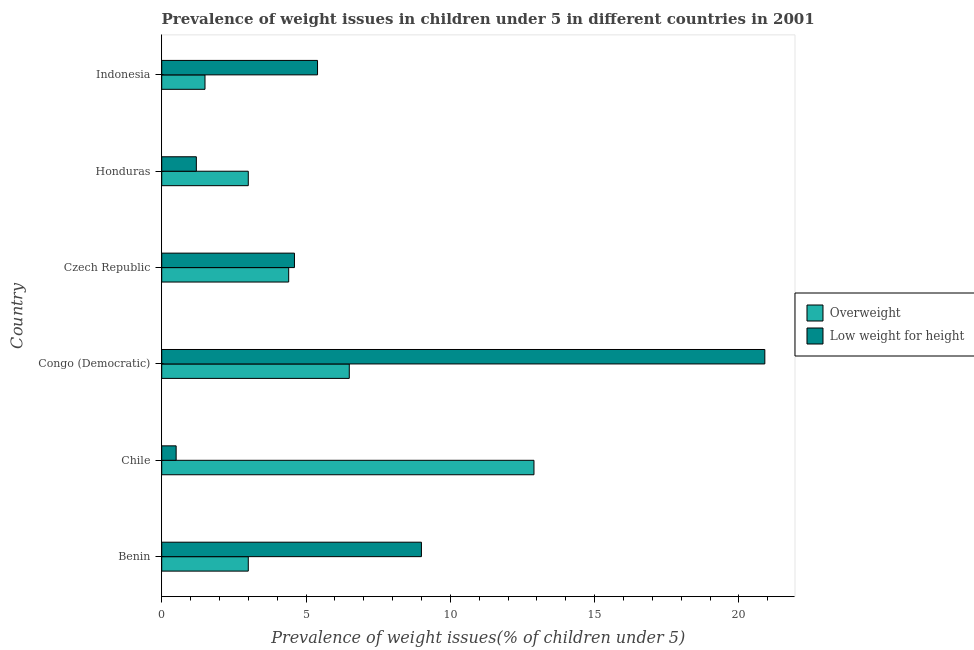How many different coloured bars are there?
Keep it short and to the point. 2. Are the number of bars per tick equal to the number of legend labels?
Offer a terse response. Yes. How many bars are there on the 5th tick from the top?
Your answer should be compact. 2. How many bars are there on the 3rd tick from the bottom?
Your response must be concise. 2. What is the label of the 3rd group of bars from the top?
Your answer should be compact. Czech Republic. Across all countries, what is the maximum percentage of overweight children?
Provide a short and direct response. 12.9. Across all countries, what is the minimum percentage of underweight children?
Your response must be concise. 0.5. What is the total percentage of overweight children in the graph?
Your response must be concise. 31.3. What is the difference between the percentage of underweight children in Benin and that in Indonesia?
Your response must be concise. 3.6. What is the difference between the percentage of overweight children in Congo (Democratic) and the percentage of underweight children in Indonesia?
Your answer should be very brief. 1.1. What is the average percentage of overweight children per country?
Provide a short and direct response. 5.22. What is the difference between the percentage of overweight children and percentage of underweight children in Congo (Democratic)?
Your answer should be very brief. -14.4. What is the ratio of the percentage of overweight children in Benin to that in Czech Republic?
Ensure brevity in your answer.  0.68. Is the percentage of underweight children in Czech Republic less than that in Honduras?
Make the answer very short. No. In how many countries, is the percentage of overweight children greater than the average percentage of overweight children taken over all countries?
Your answer should be compact. 2. What does the 2nd bar from the top in Honduras represents?
Offer a very short reply. Overweight. What does the 2nd bar from the bottom in Indonesia represents?
Make the answer very short. Low weight for height. How many bars are there?
Give a very brief answer. 12. Are the values on the major ticks of X-axis written in scientific E-notation?
Provide a short and direct response. No. Does the graph contain grids?
Provide a succinct answer. No. Where does the legend appear in the graph?
Give a very brief answer. Center right. How are the legend labels stacked?
Keep it short and to the point. Vertical. What is the title of the graph?
Offer a very short reply. Prevalence of weight issues in children under 5 in different countries in 2001. Does "Residents" appear as one of the legend labels in the graph?
Your answer should be very brief. No. What is the label or title of the X-axis?
Offer a very short reply. Prevalence of weight issues(% of children under 5). What is the Prevalence of weight issues(% of children under 5) in Overweight in Benin?
Offer a very short reply. 3. What is the Prevalence of weight issues(% of children under 5) in Overweight in Chile?
Keep it short and to the point. 12.9. What is the Prevalence of weight issues(% of children under 5) of Low weight for height in Congo (Democratic)?
Ensure brevity in your answer.  20.9. What is the Prevalence of weight issues(% of children under 5) in Overweight in Czech Republic?
Give a very brief answer. 4.4. What is the Prevalence of weight issues(% of children under 5) of Low weight for height in Czech Republic?
Your answer should be very brief. 4.6. What is the Prevalence of weight issues(% of children under 5) of Overweight in Honduras?
Keep it short and to the point. 3. What is the Prevalence of weight issues(% of children under 5) of Low weight for height in Honduras?
Ensure brevity in your answer.  1.2. What is the Prevalence of weight issues(% of children under 5) in Overweight in Indonesia?
Offer a terse response. 1.5. What is the Prevalence of weight issues(% of children under 5) in Low weight for height in Indonesia?
Your answer should be compact. 5.4. Across all countries, what is the maximum Prevalence of weight issues(% of children under 5) of Overweight?
Keep it short and to the point. 12.9. Across all countries, what is the maximum Prevalence of weight issues(% of children under 5) in Low weight for height?
Give a very brief answer. 20.9. Across all countries, what is the minimum Prevalence of weight issues(% of children under 5) of Overweight?
Make the answer very short. 1.5. Across all countries, what is the minimum Prevalence of weight issues(% of children under 5) of Low weight for height?
Ensure brevity in your answer.  0.5. What is the total Prevalence of weight issues(% of children under 5) of Overweight in the graph?
Provide a succinct answer. 31.3. What is the total Prevalence of weight issues(% of children under 5) of Low weight for height in the graph?
Your response must be concise. 41.6. What is the difference between the Prevalence of weight issues(% of children under 5) in Overweight in Benin and that in Chile?
Offer a terse response. -9.9. What is the difference between the Prevalence of weight issues(% of children under 5) in Low weight for height in Benin and that in Honduras?
Provide a short and direct response. 7.8. What is the difference between the Prevalence of weight issues(% of children under 5) in Low weight for height in Benin and that in Indonesia?
Your answer should be very brief. 3.6. What is the difference between the Prevalence of weight issues(% of children under 5) of Overweight in Chile and that in Congo (Democratic)?
Provide a succinct answer. 6.4. What is the difference between the Prevalence of weight issues(% of children under 5) of Low weight for height in Chile and that in Congo (Democratic)?
Your answer should be compact. -20.4. What is the difference between the Prevalence of weight issues(% of children under 5) of Overweight in Congo (Democratic) and that in Czech Republic?
Provide a succinct answer. 2.1. What is the difference between the Prevalence of weight issues(% of children under 5) of Low weight for height in Congo (Democratic) and that in Czech Republic?
Offer a very short reply. 16.3. What is the difference between the Prevalence of weight issues(% of children under 5) of Low weight for height in Congo (Democratic) and that in Honduras?
Keep it short and to the point. 19.7. What is the difference between the Prevalence of weight issues(% of children under 5) in Overweight in Congo (Democratic) and that in Indonesia?
Your answer should be compact. 5. What is the difference between the Prevalence of weight issues(% of children under 5) of Low weight for height in Congo (Democratic) and that in Indonesia?
Provide a succinct answer. 15.5. What is the difference between the Prevalence of weight issues(% of children under 5) of Overweight in Czech Republic and that in Honduras?
Provide a succinct answer. 1.4. What is the difference between the Prevalence of weight issues(% of children under 5) of Low weight for height in Czech Republic and that in Indonesia?
Ensure brevity in your answer.  -0.8. What is the difference between the Prevalence of weight issues(% of children under 5) of Overweight in Honduras and that in Indonesia?
Provide a short and direct response. 1.5. What is the difference between the Prevalence of weight issues(% of children under 5) in Overweight in Benin and the Prevalence of weight issues(% of children under 5) in Low weight for height in Congo (Democratic)?
Offer a very short reply. -17.9. What is the difference between the Prevalence of weight issues(% of children under 5) in Overweight in Benin and the Prevalence of weight issues(% of children under 5) in Low weight for height in Indonesia?
Your answer should be compact. -2.4. What is the difference between the Prevalence of weight issues(% of children under 5) in Overweight in Chile and the Prevalence of weight issues(% of children under 5) in Low weight for height in Congo (Democratic)?
Provide a succinct answer. -8. What is the difference between the Prevalence of weight issues(% of children under 5) in Overweight in Chile and the Prevalence of weight issues(% of children under 5) in Low weight for height in Indonesia?
Provide a short and direct response. 7.5. What is the difference between the Prevalence of weight issues(% of children under 5) in Overweight in Congo (Democratic) and the Prevalence of weight issues(% of children under 5) in Low weight for height in Czech Republic?
Your answer should be compact. 1.9. What is the difference between the Prevalence of weight issues(% of children under 5) of Overweight in Congo (Democratic) and the Prevalence of weight issues(% of children under 5) of Low weight for height in Honduras?
Provide a succinct answer. 5.3. What is the difference between the Prevalence of weight issues(% of children under 5) of Overweight in Congo (Democratic) and the Prevalence of weight issues(% of children under 5) of Low weight for height in Indonesia?
Your response must be concise. 1.1. What is the difference between the Prevalence of weight issues(% of children under 5) of Overweight in Czech Republic and the Prevalence of weight issues(% of children under 5) of Low weight for height in Honduras?
Your answer should be very brief. 3.2. What is the difference between the Prevalence of weight issues(% of children under 5) in Overweight in Czech Republic and the Prevalence of weight issues(% of children under 5) in Low weight for height in Indonesia?
Offer a terse response. -1. What is the average Prevalence of weight issues(% of children under 5) of Overweight per country?
Provide a succinct answer. 5.22. What is the average Prevalence of weight issues(% of children under 5) of Low weight for height per country?
Provide a succinct answer. 6.93. What is the difference between the Prevalence of weight issues(% of children under 5) in Overweight and Prevalence of weight issues(% of children under 5) in Low weight for height in Benin?
Offer a very short reply. -6. What is the difference between the Prevalence of weight issues(% of children under 5) in Overweight and Prevalence of weight issues(% of children under 5) in Low weight for height in Chile?
Give a very brief answer. 12.4. What is the difference between the Prevalence of weight issues(% of children under 5) of Overweight and Prevalence of weight issues(% of children under 5) of Low weight for height in Congo (Democratic)?
Offer a very short reply. -14.4. What is the difference between the Prevalence of weight issues(% of children under 5) in Overweight and Prevalence of weight issues(% of children under 5) in Low weight for height in Czech Republic?
Offer a very short reply. -0.2. What is the ratio of the Prevalence of weight issues(% of children under 5) in Overweight in Benin to that in Chile?
Provide a short and direct response. 0.23. What is the ratio of the Prevalence of weight issues(% of children under 5) in Overweight in Benin to that in Congo (Democratic)?
Give a very brief answer. 0.46. What is the ratio of the Prevalence of weight issues(% of children under 5) of Low weight for height in Benin to that in Congo (Democratic)?
Provide a short and direct response. 0.43. What is the ratio of the Prevalence of weight issues(% of children under 5) in Overweight in Benin to that in Czech Republic?
Your response must be concise. 0.68. What is the ratio of the Prevalence of weight issues(% of children under 5) of Low weight for height in Benin to that in Czech Republic?
Keep it short and to the point. 1.96. What is the ratio of the Prevalence of weight issues(% of children under 5) in Overweight in Chile to that in Congo (Democratic)?
Provide a succinct answer. 1.98. What is the ratio of the Prevalence of weight issues(% of children under 5) in Low weight for height in Chile to that in Congo (Democratic)?
Give a very brief answer. 0.02. What is the ratio of the Prevalence of weight issues(% of children under 5) in Overweight in Chile to that in Czech Republic?
Make the answer very short. 2.93. What is the ratio of the Prevalence of weight issues(% of children under 5) of Low weight for height in Chile to that in Czech Republic?
Your answer should be very brief. 0.11. What is the ratio of the Prevalence of weight issues(% of children under 5) of Overweight in Chile to that in Honduras?
Your answer should be compact. 4.3. What is the ratio of the Prevalence of weight issues(% of children under 5) of Low weight for height in Chile to that in Honduras?
Your answer should be compact. 0.42. What is the ratio of the Prevalence of weight issues(% of children under 5) of Low weight for height in Chile to that in Indonesia?
Make the answer very short. 0.09. What is the ratio of the Prevalence of weight issues(% of children under 5) in Overweight in Congo (Democratic) to that in Czech Republic?
Give a very brief answer. 1.48. What is the ratio of the Prevalence of weight issues(% of children under 5) in Low weight for height in Congo (Democratic) to that in Czech Republic?
Ensure brevity in your answer.  4.54. What is the ratio of the Prevalence of weight issues(% of children under 5) of Overweight in Congo (Democratic) to that in Honduras?
Keep it short and to the point. 2.17. What is the ratio of the Prevalence of weight issues(% of children under 5) of Low weight for height in Congo (Democratic) to that in Honduras?
Ensure brevity in your answer.  17.42. What is the ratio of the Prevalence of weight issues(% of children under 5) of Overweight in Congo (Democratic) to that in Indonesia?
Your response must be concise. 4.33. What is the ratio of the Prevalence of weight issues(% of children under 5) of Low weight for height in Congo (Democratic) to that in Indonesia?
Your response must be concise. 3.87. What is the ratio of the Prevalence of weight issues(% of children under 5) in Overweight in Czech Republic to that in Honduras?
Ensure brevity in your answer.  1.47. What is the ratio of the Prevalence of weight issues(% of children under 5) of Low weight for height in Czech Republic to that in Honduras?
Give a very brief answer. 3.83. What is the ratio of the Prevalence of weight issues(% of children under 5) in Overweight in Czech Republic to that in Indonesia?
Make the answer very short. 2.93. What is the ratio of the Prevalence of weight issues(% of children under 5) of Low weight for height in Czech Republic to that in Indonesia?
Give a very brief answer. 0.85. What is the ratio of the Prevalence of weight issues(% of children under 5) of Low weight for height in Honduras to that in Indonesia?
Make the answer very short. 0.22. What is the difference between the highest and the second highest Prevalence of weight issues(% of children under 5) in Low weight for height?
Give a very brief answer. 11.9. What is the difference between the highest and the lowest Prevalence of weight issues(% of children under 5) in Low weight for height?
Offer a terse response. 20.4. 